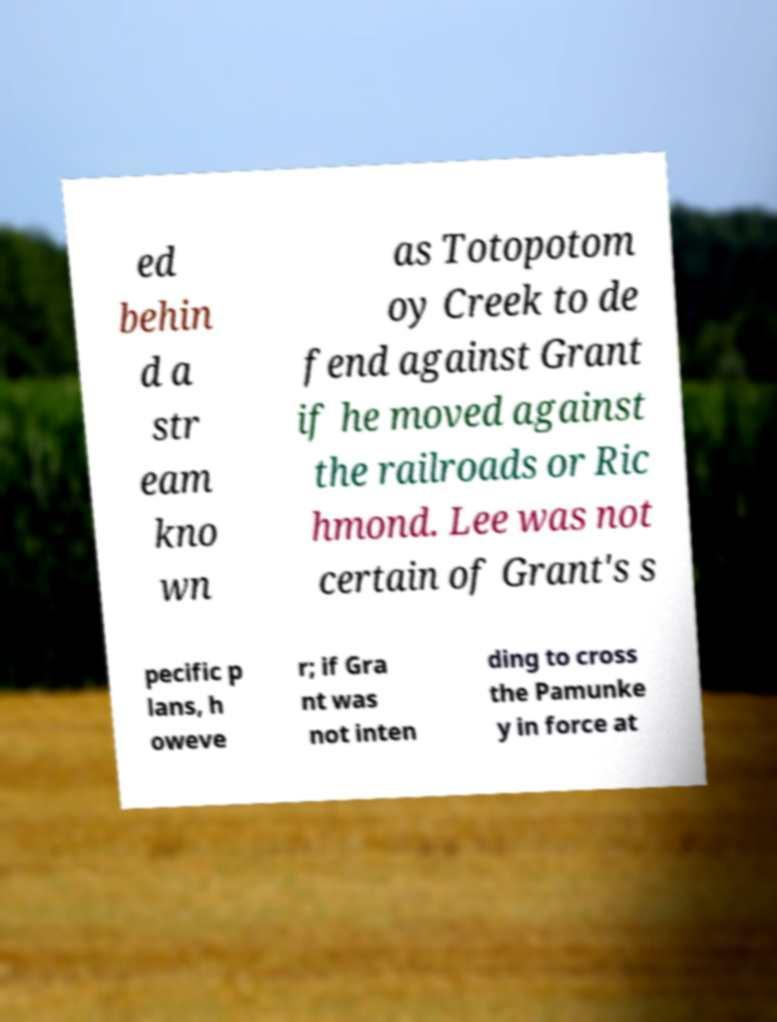Can you accurately transcribe the text from the provided image for me? ed behin d a str eam kno wn as Totopotom oy Creek to de fend against Grant if he moved against the railroads or Ric hmond. Lee was not certain of Grant's s pecific p lans, h oweve r; if Gra nt was not inten ding to cross the Pamunke y in force at 